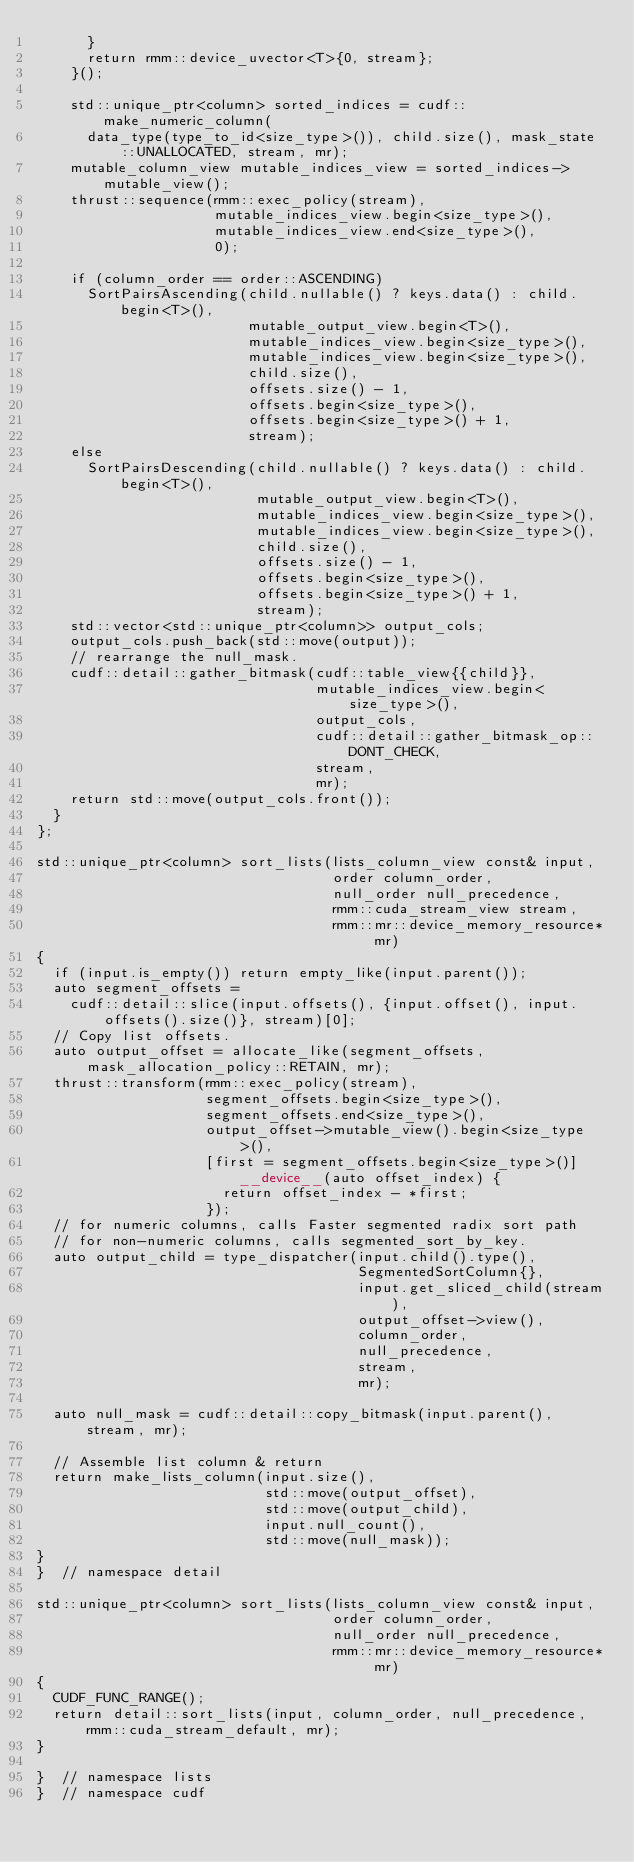Convert code to text. <code><loc_0><loc_0><loc_500><loc_500><_Cuda_>      }
      return rmm::device_uvector<T>{0, stream};
    }();

    std::unique_ptr<column> sorted_indices = cudf::make_numeric_column(
      data_type(type_to_id<size_type>()), child.size(), mask_state::UNALLOCATED, stream, mr);
    mutable_column_view mutable_indices_view = sorted_indices->mutable_view();
    thrust::sequence(rmm::exec_policy(stream),
                     mutable_indices_view.begin<size_type>(),
                     mutable_indices_view.end<size_type>(),
                     0);

    if (column_order == order::ASCENDING)
      SortPairsAscending(child.nullable() ? keys.data() : child.begin<T>(),
                         mutable_output_view.begin<T>(),
                         mutable_indices_view.begin<size_type>(),
                         mutable_indices_view.begin<size_type>(),
                         child.size(),
                         offsets.size() - 1,
                         offsets.begin<size_type>(),
                         offsets.begin<size_type>() + 1,
                         stream);
    else
      SortPairsDescending(child.nullable() ? keys.data() : child.begin<T>(),
                          mutable_output_view.begin<T>(),
                          mutable_indices_view.begin<size_type>(),
                          mutable_indices_view.begin<size_type>(),
                          child.size(),
                          offsets.size() - 1,
                          offsets.begin<size_type>(),
                          offsets.begin<size_type>() + 1,
                          stream);
    std::vector<std::unique_ptr<column>> output_cols;
    output_cols.push_back(std::move(output));
    // rearrange the null_mask.
    cudf::detail::gather_bitmask(cudf::table_view{{child}},
                                 mutable_indices_view.begin<size_type>(),
                                 output_cols,
                                 cudf::detail::gather_bitmask_op::DONT_CHECK,
                                 stream,
                                 mr);
    return std::move(output_cols.front());
  }
};

std::unique_ptr<column> sort_lists(lists_column_view const& input,
                                   order column_order,
                                   null_order null_precedence,
                                   rmm::cuda_stream_view stream,
                                   rmm::mr::device_memory_resource* mr)
{
  if (input.is_empty()) return empty_like(input.parent());
  auto segment_offsets =
    cudf::detail::slice(input.offsets(), {input.offset(), input.offsets().size()}, stream)[0];
  // Copy list offsets.
  auto output_offset = allocate_like(segment_offsets, mask_allocation_policy::RETAIN, mr);
  thrust::transform(rmm::exec_policy(stream),
                    segment_offsets.begin<size_type>(),
                    segment_offsets.end<size_type>(),
                    output_offset->mutable_view().begin<size_type>(),
                    [first = segment_offsets.begin<size_type>()] __device__(auto offset_index) {
                      return offset_index - *first;
                    });
  // for numeric columns, calls Faster segmented radix sort path
  // for non-numeric columns, calls segmented_sort_by_key.
  auto output_child = type_dispatcher(input.child().type(),
                                      SegmentedSortColumn{},
                                      input.get_sliced_child(stream),
                                      output_offset->view(),
                                      column_order,
                                      null_precedence,
                                      stream,
                                      mr);

  auto null_mask = cudf::detail::copy_bitmask(input.parent(), stream, mr);

  // Assemble list column & return
  return make_lists_column(input.size(),
                           std::move(output_offset),
                           std::move(output_child),
                           input.null_count(),
                           std::move(null_mask));
}
}  // namespace detail

std::unique_ptr<column> sort_lists(lists_column_view const& input,
                                   order column_order,
                                   null_order null_precedence,
                                   rmm::mr::device_memory_resource* mr)
{
  CUDF_FUNC_RANGE();
  return detail::sort_lists(input, column_order, null_precedence, rmm::cuda_stream_default, mr);
}

}  // namespace lists
}  // namespace cudf
</code> 